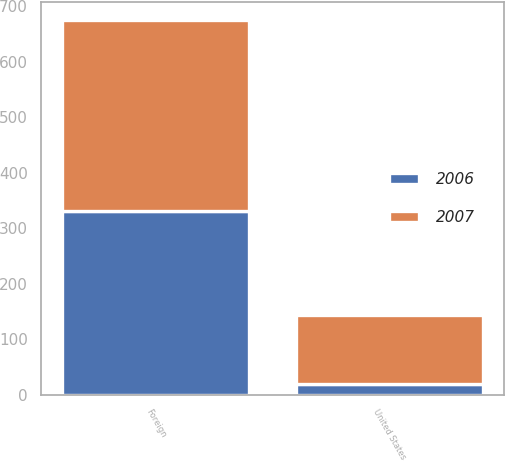<chart> <loc_0><loc_0><loc_500><loc_500><stacked_bar_chart><ecel><fcel>United States<fcel>Foreign<nl><fcel>2007<fcel>124<fcel>343<nl><fcel>2006<fcel>19<fcel>332<nl></chart> 